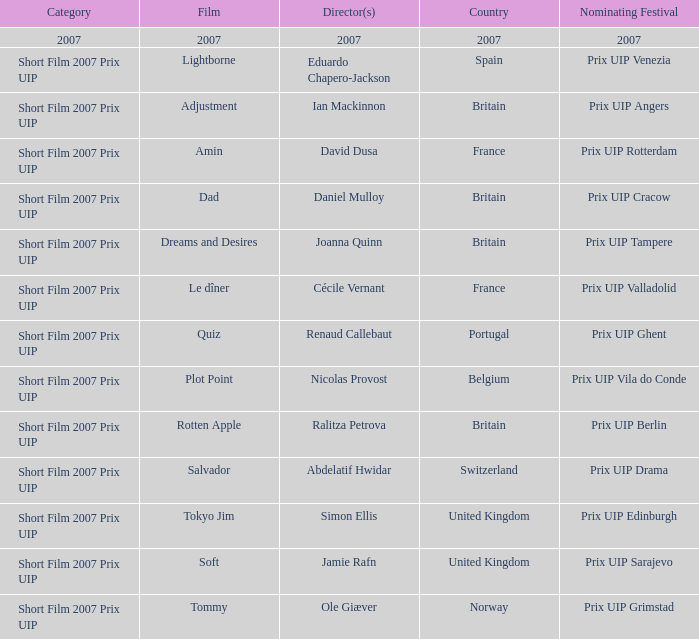In the 2007 prix uip category for short films, which movie was directed by ian mackinnon? Adjustment. 